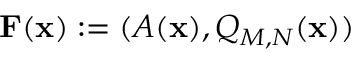<formula> <loc_0><loc_0><loc_500><loc_500>F ( x ) \colon = ( A ( x ) , Q _ { M , N } ( x ) )</formula> 